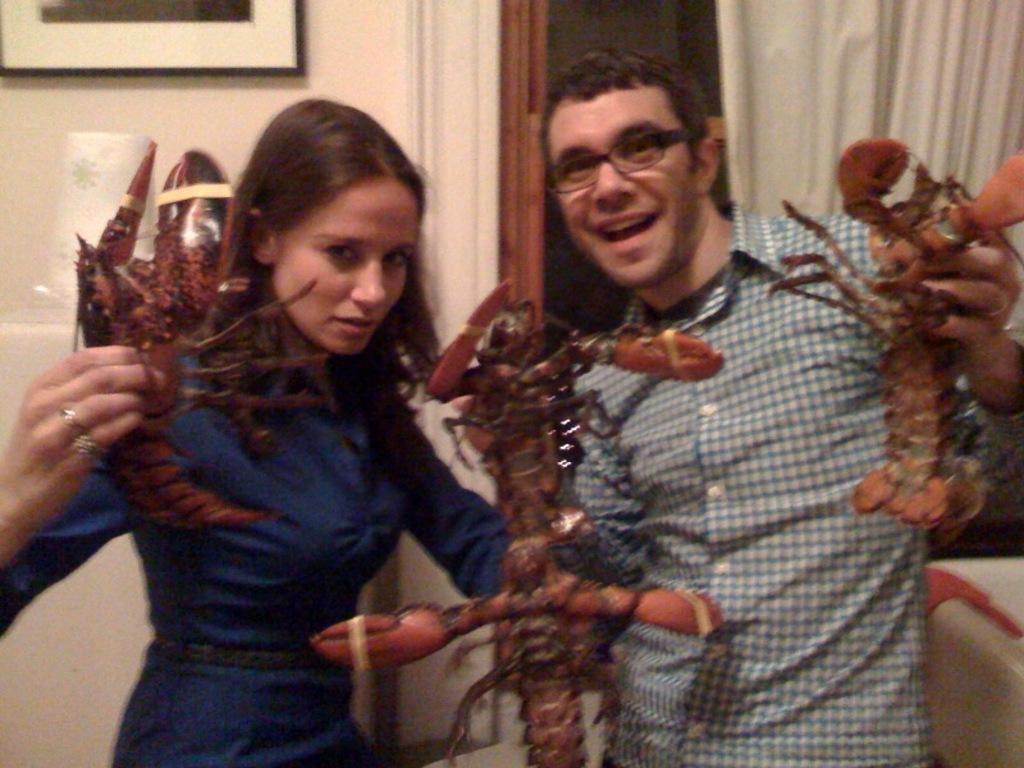Can you describe this image briefly? In this image there is a couple holding crabs in their hands is posing for the camera with a smile on their face, behind them there is paper napkin, above the paper napkin there is a photo frame on the wall and there are curtains on the glass window. 